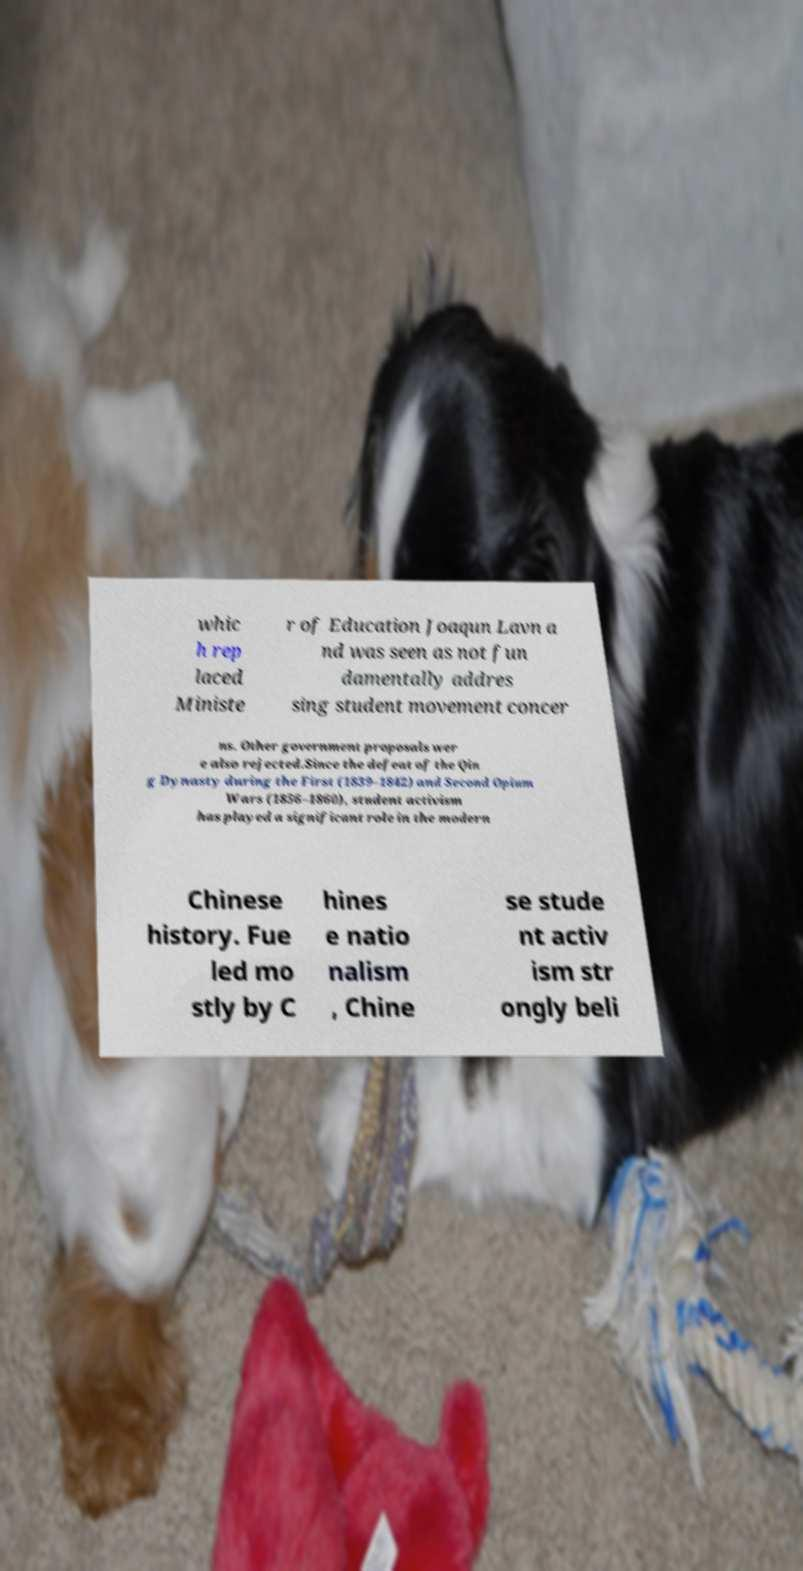I need the written content from this picture converted into text. Can you do that? whic h rep laced Ministe r of Education Joaqun Lavn a nd was seen as not fun damentally addres sing student movement concer ns. Other government proposals wer e also rejected.Since the defeat of the Qin g Dynasty during the First (1839–1842) and Second Opium Wars (1856–1860), student activism has played a significant role in the modern Chinese history. Fue led mo stly by C hines e natio nalism , Chine se stude nt activ ism str ongly beli 